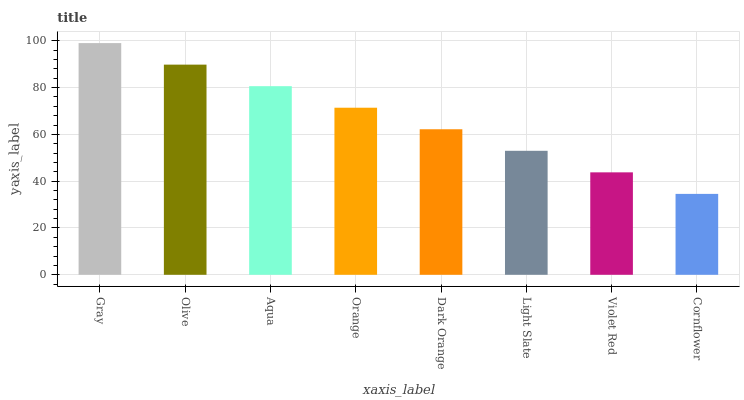Is Cornflower the minimum?
Answer yes or no. Yes. Is Gray the maximum?
Answer yes or no. Yes. Is Olive the minimum?
Answer yes or no. No. Is Olive the maximum?
Answer yes or no. No. Is Gray greater than Olive?
Answer yes or no. Yes. Is Olive less than Gray?
Answer yes or no. Yes. Is Olive greater than Gray?
Answer yes or no. No. Is Gray less than Olive?
Answer yes or no. No. Is Orange the high median?
Answer yes or no. Yes. Is Dark Orange the low median?
Answer yes or no. Yes. Is Dark Orange the high median?
Answer yes or no. No. Is Olive the low median?
Answer yes or no. No. 